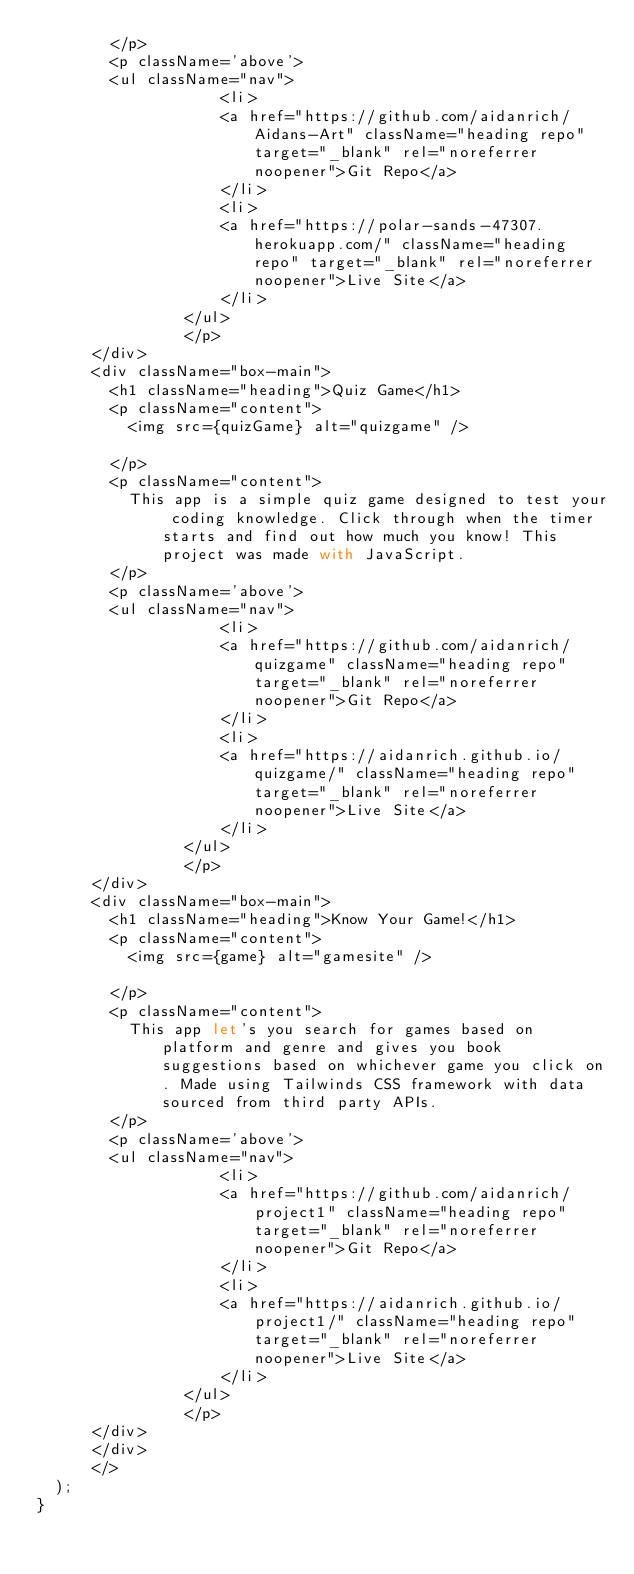<code> <loc_0><loc_0><loc_500><loc_500><_JavaScript_>        </p>
        <p className='above'>
        <ul className="nav">
                    <li>
                    <a href="https://github.com/aidanrich/Aidans-Art" className="heading repo" target="_blank" rel="noreferrer noopener">Git Repo</a>
                    </li>
                    <li>
                    <a href="https://polar-sands-47307.herokuapp.com/" className="heading repo" target="_blank" rel="noreferrer noopener">Live Site</a>
                    </li>
                </ul>
                </p>
      </div>
      <div className="box-main">
        <h1 className="heading">Quiz Game</h1>
        <p className="content">
          <img src={quizGame} alt="quizgame" />

        </p>
        <p className="content">
          This app is a simple quiz game designed to test your coding knowledge. Click through when the timer starts and find out how much you know! This project was made with JavaScript.
        </p>
        <p className='above'>
        <ul className="nav">
                    <li>
                    <a href="https://github.com/aidanrich/quizgame" className="heading repo" target="_blank" rel="noreferrer noopener">Git Repo</a>
                    </li>
                    <li>
                    <a href="https://aidanrich.github.io/quizgame/" className="heading repo" target="_blank" rel="noreferrer noopener">Live Site</a>
                    </li>
                </ul>
                </p>
      </div>
      <div className="box-main">
        <h1 className="heading">Know Your Game!</h1>
        <p className="content">
          <img src={game} alt="gamesite" />

        </p>
        <p className="content">
          This app let's you search for games based on platform and genre and gives you book suggestions based on whichever game you click on. Made using Tailwinds CSS framework with data sourced from third party APIs.
        </p>
        <p className='above'>
        <ul className="nav">
                    <li>
                    <a href="https://github.com/aidanrich/project1" className="heading repo" target="_blank" rel="noreferrer noopener">Git Repo</a>
                    </li>
                    <li>
                    <a href="https://aidanrich.github.io/project1/" className="heading repo" target="_blank" rel="noreferrer noopener">Live Site</a>
                    </li>
                </ul>
                </p>
      </div>
      </div>
      </>
  );
}
</code> 